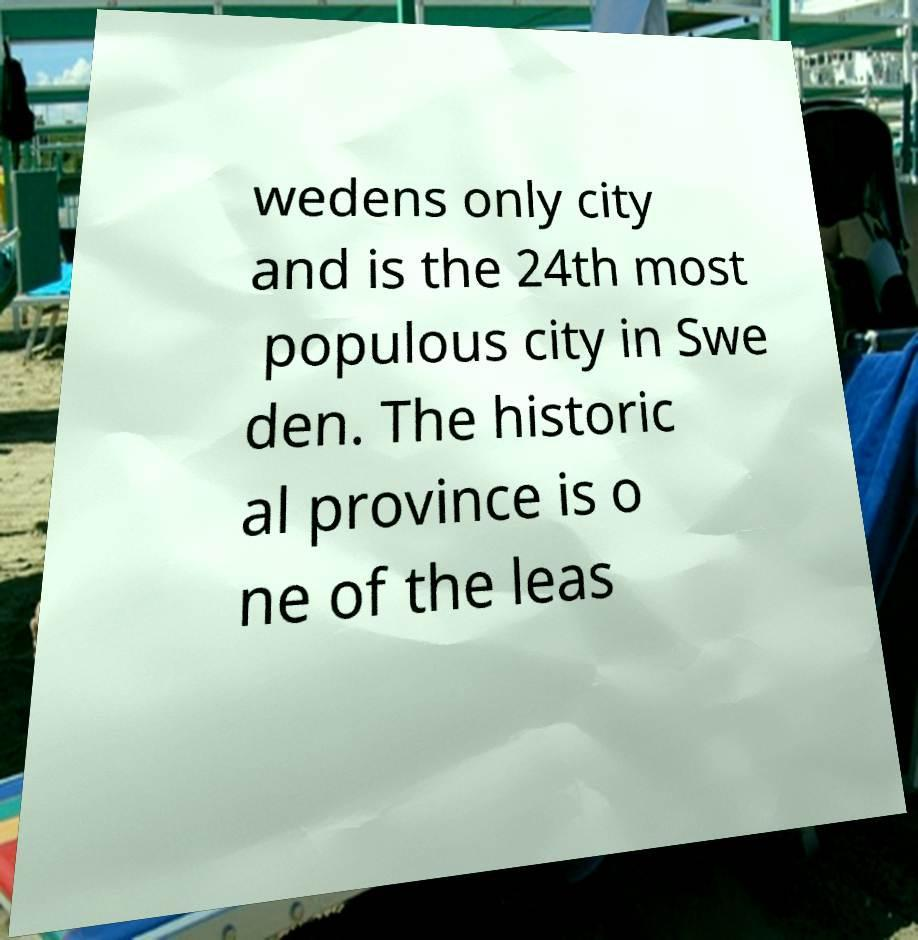Please identify and transcribe the text found in this image. wedens only city and is the 24th most populous city in Swe den. The historic al province is o ne of the leas 